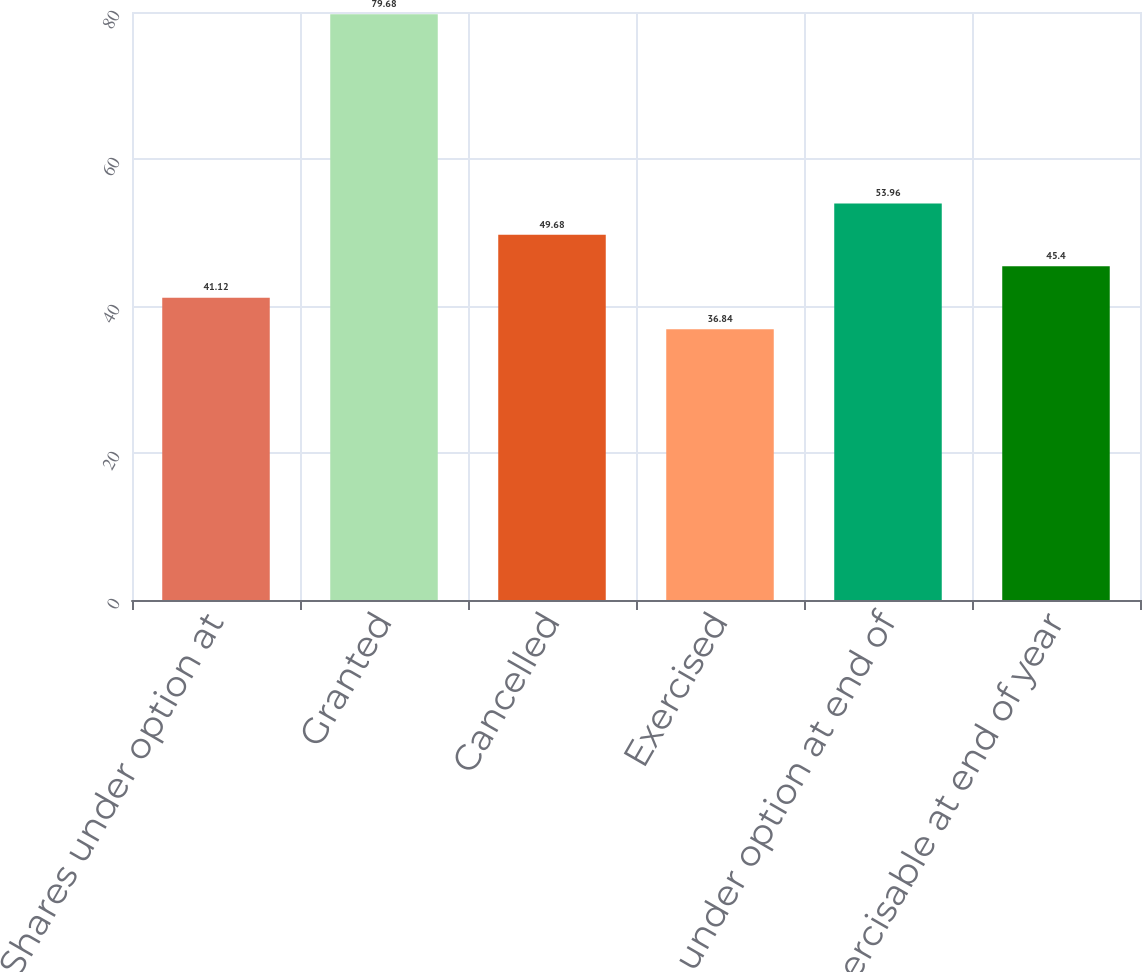<chart> <loc_0><loc_0><loc_500><loc_500><bar_chart><fcel>Shares under option at<fcel>Granted<fcel>Cancelled<fcel>Exercised<fcel>Shares under option at end of<fcel>Exercisable at end of year<nl><fcel>41.12<fcel>79.68<fcel>49.68<fcel>36.84<fcel>53.96<fcel>45.4<nl></chart> 